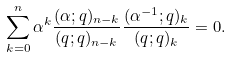<formula> <loc_0><loc_0><loc_500><loc_500>\sum _ { k = 0 } ^ { n } \alpha ^ { k } \frac { ( \alpha ; q ) _ { n - k } } { ( q ; q ) _ { n - k } } \frac { ( \alpha ^ { - 1 } ; q ) _ { k } } { ( q ; q ) _ { k } } = 0 .</formula> 